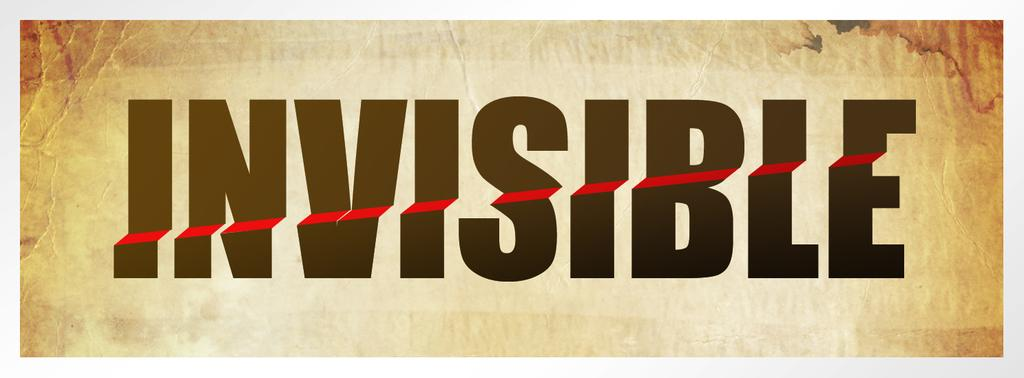<image>
Render a clear and concise summary of the photo. Large block letters that spell Invisible with a red line going through them. 